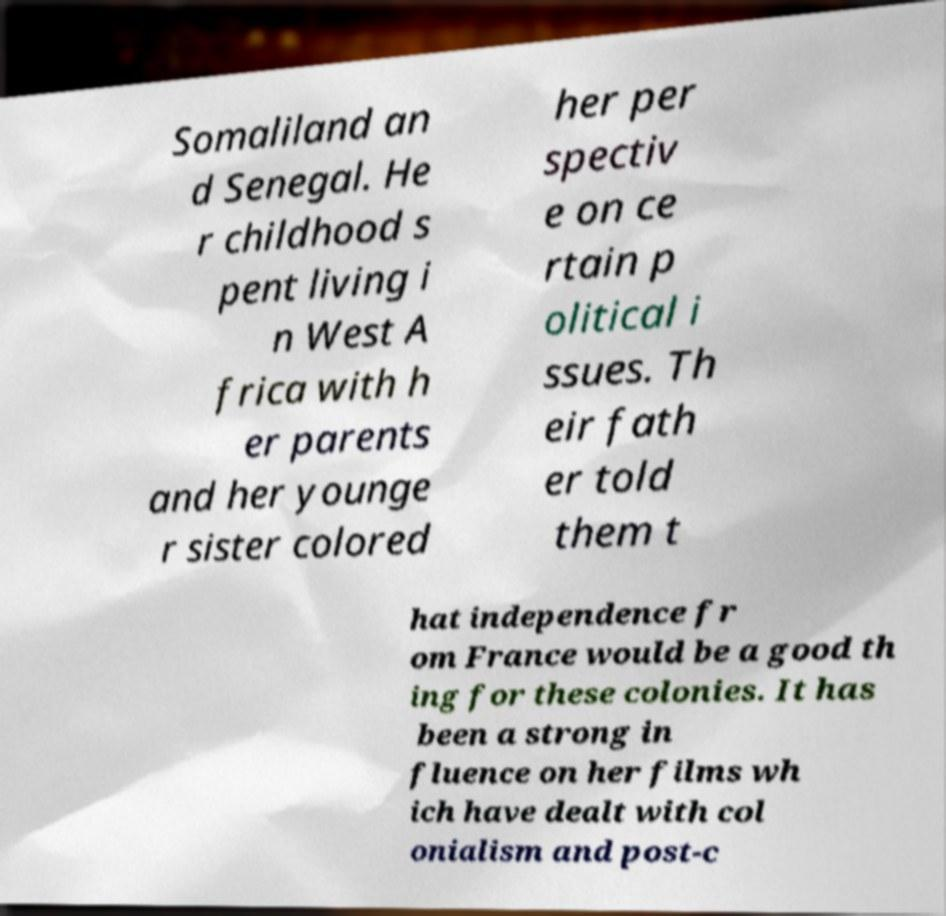Could you assist in decoding the text presented in this image and type it out clearly? Somaliland an d Senegal. He r childhood s pent living i n West A frica with h er parents and her younge r sister colored her per spectiv e on ce rtain p olitical i ssues. Th eir fath er told them t hat independence fr om France would be a good th ing for these colonies. It has been a strong in fluence on her films wh ich have dealt with col onialism and post-c 